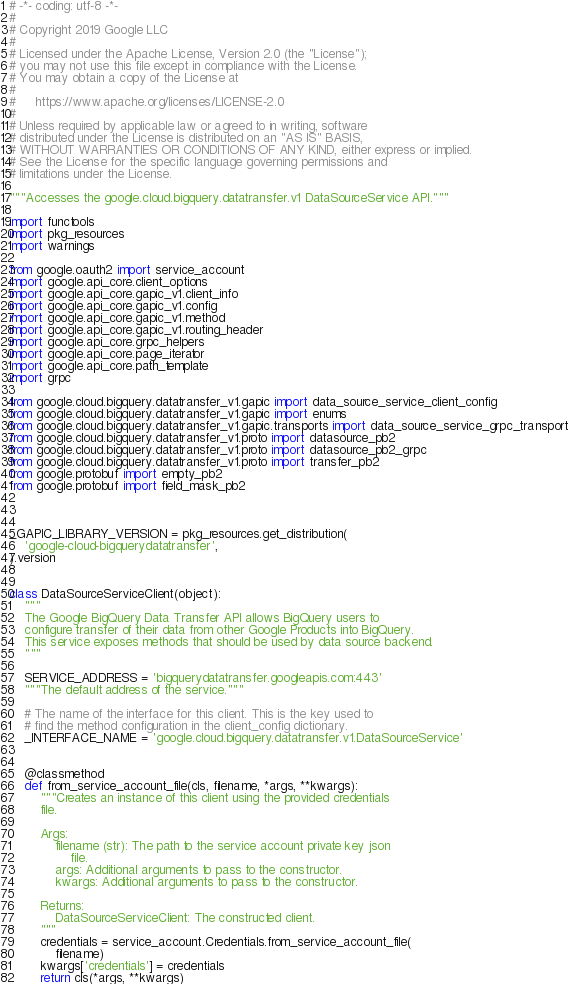<code> <loc_0><loc_0><loc_500><loc_500><_Python_># -*- coding: utf-8 -*-
#
# Copyright 2019 Google LLC
#
# Licensed under the Apache License, Version 2.0 (the "License");
# you may not use this file except in compliance with the License.
# You may obtain a copy of the License at
#
#     https://www.apache.org/licenses/LICENSE-2.0
#
# Unless required by applicable law or agreed to in writing, software
# distributed under the License is distributed on an "AS IS" BASIS,
# WITHOUT WARRANTIES OR CONDITIONS OF ANY KIND, either express or implied.
# See the License for the specific language governing permissions and
# limitations under the License.

"""Accesses the google.cloud.bigquery.datatransfer.v1 DataSourceService API."""

import functools
import pkg_resources
import warnings

from google.oauth2 import service_account
import google.api_core.client_options
import google.api_core.gapic_v1.client_info
import google.api_core.gapic_v1.config
import google.api_core.gapic_v1.method
import google.api_core.gapic_v1.routing_header
import google.api_core.grpc_helpers
import google.api_core.page_iterator
import google.api_core.path_template
import grpc

from google.cloud.bigquery.datatransfer_v1.gapic import data_source_service_client_config
from google.cloud.bigquery.datatransfer_v1.gapic import enums
from google.cloud.bigquery.datatransfer_v1.gapic.transports import data_source_service_grpc_transport
from google.cloud.bigquery.datatransfer_v1.proto import datasource_pb2
from google.cloud.bigquery.datatransfer_v1.proto import datasource_pb2_grpc
from google.cloud.bigquery.datatransfer_v1.proto import transfer_pb2
from google.protobuf import empty_pb2
from google.protobuf import field_mask_pb2



_GAPIC_LIBRARY_VERSION = pkg_resources.get_distribution(
    'google-cloud-bigquerydatatransfer',
).version


class DataSourceServiceClient(object):
    """
    The Google BigQuery Data Transfer API allows BigQuery users to
    configure transfer of their data from other Google Products into BigQuery.
    This service exposes methods that should be used by data source backend.
    """

    SERVICE_ADDRESS = 'bigquerydatatransfer.googleapis.com:443'
    """The default address of the service."""

    # The name of the interface for this client. This is the key used to
    # find the method configuration in the client_config dictionary.
    _INTERFACE_NAME = 'google.cloud.bigquery.datatransfer.v1.DataSourceService'


    @classmethod
    def from_service_account_file(cls, filename, *args, **kwargs):
        """Creates an instance of this client using the provided credentials
        file.

        Args:
            filename (str): The path to the service account private key json
                file.
            args: Additional arguments to pass to the constructor.
            kwargs: Additional arguments to pass to the constructor.

        Returns:
            DataSourceServiceClient: The constructed client.
        """
        credentials = service_account.Credentials.from_service_account_file(
            filename)
        kwargs['credentials'] = credentials
        return cls(*args, **kwargs)
</code> 